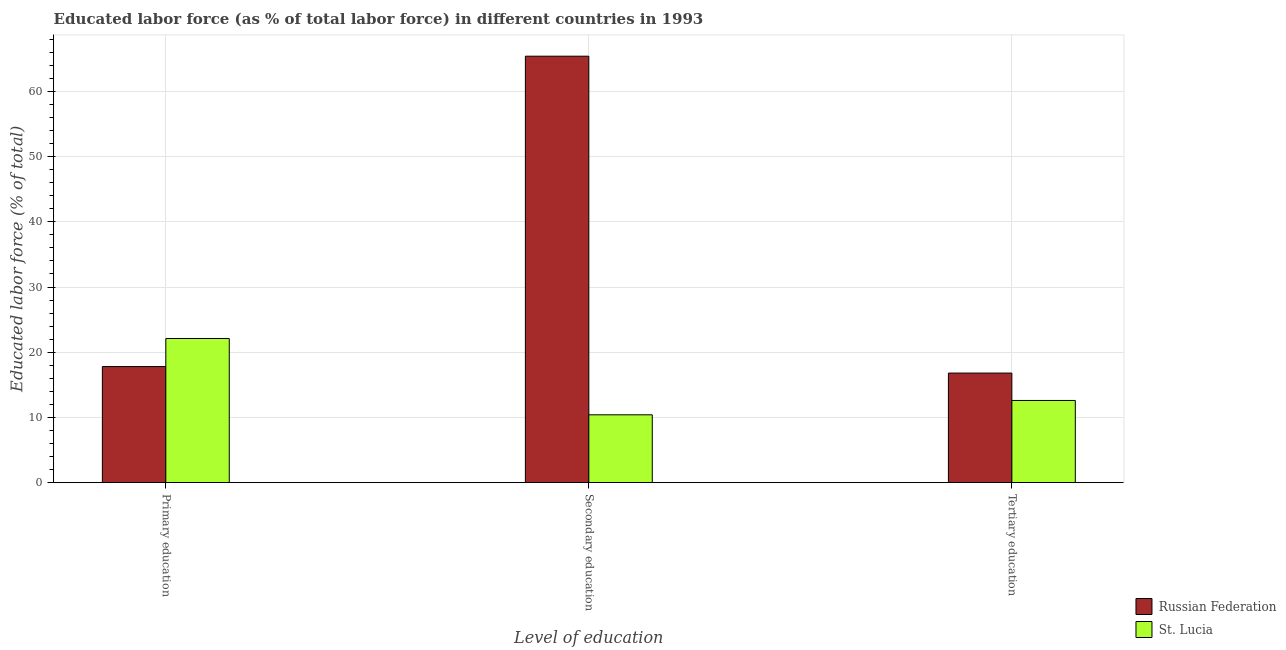How many groups of bars are there?
Offer a very short reply. 3. How many bars are there on the 3rd tick from the left?
Make the answer very short. 2. What is the label of the 3rd group of bars from the left?
Provide a succinct answer. Tertiary education. What is the percentage of labor force who received tertiary education in St. Lucia?
Offer a very short reply. 12.6. Across all countries, what is the maximum percentage of labor force who received tertiary education?
Give a very brief answer. 16.8. Across all countries, what is the minimum percentage of labor force who received tertiary education?
Provide a short and direct response. 12.6. In which country was the percentage of labor force who received secondary education maximum?
Offer a terse response. Russian Federation. In which country was the percentage of labor force who received tertiary education minimum?
Your response must be concise. St. Lucia. What is the total percentage of labor force who received tertiary education in the graph?
Provide a succinct answer. 29.4. What is the difference between the percentage of labor force who received secondary education in St. Lucia and that in Russian Federation?
Your answer should be very brief. -55. What is the difference between the percentage of labor force who received secondary education in Russian Federation and the percentage of labor force who received primary education in St. Lucia?
Make the answer very short. 43.3. What is the average percentage of labor force who received primary education per country?
Ensure brevity in your answer.  19.95. What is the difference between the percentage of labor force who received secondary education and percentage of labor force who received primary education in St. Lucia?
Your response must be concise. -11.7. In how many countries, is the percentage of labor force who received primary education greater than 16 %?
Your answer should be very brief. 2. What is the ratio of the percentage of labor force who received primary education in Russian Federation to that in St. Lucia?
Ensure brevity in your answer.  0.81. What is the difference between the highest and the second highest percentage of labor force who received secondary education?
Offer a terse response. 55. What is the difference between the highest and the lowest percentage of labor force who received secondary education?
Your answer should be very brief. 55. In how many countries, is the percentage of labor force who received primary education greater than the average percentage of labor force who received primary education taken over all countries?
Provide a short and direct response. 1. What does the 1st bar from the left in Secondary education represents?
Offer a very short reply. Russian Federation. What does the 2nd bar from the right in Tertiary education represents?
Ensure brevity in your answer.  Russian Federation. How many bars are there?
Your response must be concise. 6. How many countries are there in the graph?
Ensure brevity in your answer.  2. What is the difference between two consecutive major ticks on the Y-axis?
Ensure brevity in your answer.  10. Are the values on the major ticks of Y-axis written in scientific E-notation?
Offer a very short reply. No. Does the graph contain any zero values?
Provide a short and direct response. No. Does the graph contain grids?
Provide a short and direct response. Yes. Where does the legend appear in the graph?
Offer a very short reply. Bottom right. What is the title of the graph?
Offer a terse response. Educated labor force (as % of total labor force) in different countries in 1993. What is the label or title of the X-axis?
Keep it short and to the point. Level of education. What is the label or title of the Y-axis?
Provide a short and direct response. Educated labor force (% of total). What is the Educated labor force (% of total) in Russian Federation in Primary education?
Your response must be concise. 17.8. What is the Educated labor force (% of total) in St. Lucia in Primary education?
Your response must be concise. 22.1. What is the Educated labor force (% of total) in Russian Federation in Secondary education?
Ensure brevity in your answer.  65.4. What is the Educated labor force (% of total) in St. Lucia in Secondary education?
Your answer should be compact. 10.4. What is the Educated labor force (% of total) in Russian Federation in Tertiary education?
Your answer should be very brief. 16.8. What is the Educated labor force (% of total) of St. Lucia in Tertiary education?
Offer a very short reply. 12.6. Across all Level of education, what is the maximum Educated labor force (% of total) of Russian Federation?
Your answer should be compact. 65.4. Across all Level of education, what is the maximum Educated labor force (% of total) of St. Lucia?
Ensure brevity in your answer.  22.1. Across all Level of education, what is the minimum Educated labor force (% of total) of Russian Federation?
Keep it short and to the point. 16.8. Across all Level of education, what is the minimum Educated labor force (% of total) of St. Lucia?
Your answer should be very brief. 10.4. What is the total Educated labor force (% of total) in Russian Federation in the graph?
Your response must be concise. 100. What is the total Educated labor force (% of total) in St. Lucia in the graph?
Your answer should be very brief. 45.1. What is the difference between the Educated labor force (% of total) of Russian Federation in Primary education and that in Secondary education?
Provide a succinct answer. -47.6. What is the difference between the Educated labor force (% of total) in St. Lucia in Primary education and that in Secondary education?
Offer a very short reply. 11.7. What is the difference between the Educated labor force (% of total) of Russian Federation in Primary education and that in Tertiary education?
Ensure brevity in your answer.  1. What is the difference between the Educated labor force (% of total) in Russian Federation in Secondary education and that in Tertiary education?
Make the answer very short. 48.6. What is the difference between the Educated labor force (% of total) of St. Lucia in Secondary education and that in Tertiary education?
Keep it short and to the point. -2.2. What is the difference between the Educated labor force (% of total) of Russian Federation in Primary education and the Educated labor force (% of total) of St. Lucia in Tertiary education?
Your answer should be compact. 5.2. What is the difference between the Educated labor force (% of total) in Russian Federation in Secondary education and the Educated labor force (% of total) in St. Lucia in Tertiary education?
Offer a very short reply. 52.8. What is the average Educated labor force (% of total) in Russian Federation per Level of education?
Provide a succinct answer. 33.33. What is the average Educated labor force (% of total) in St. Lucia per Level of education?
Your response must be concise. 15.03. What is the difference between the Educated labor force (% of total) in Russian Federation and Educated labor force (% of total) in St. Lucia in Primary education?
Offer a terse response. -4.3. What is the difference between the Educated labor force (% of total) of Russian Federation and Educated labor force (% of total) of St. Lucia in Secondary education?
Provide a succinct answer. 55. What is the difference between the Educated labor force (% of total) in Russian Federation and Educated labor force (% of total) in St. Lucia in Tertiary education?
Provide a succinct answer. 4.2. What is the ratio of the Educated labor force (% of total) of Russian Federation in Primary education to that in Secondary education?
Offer a very short reply. 0.27. What is the ratio of the Educated labor force (% of total) in St. Lucia in Primary education to that in Secondary education?
Your response must be concise. 2.12. What is the ratio of the Educated labor force (% of total) of Russian Federation in Primary education to that in Tertiary education?
Keep it short and to the point. 1.06. What is the ratio of the Educated labor force (% of total) of St. Lucia in Primary education to that in Tertiary education?
Provide a succinct answer. 1.75. What is the ratio of the Educated labor force (% of total) in Russian Federation in Secondary education to that in Tertiary education?
Give a very brief answer. 3.89. What is the ratio of the Educated labor force (% of total) of St. Lucia in Secondary education to that in Tertiary education?
Give a very brief answer. 0.83. What is the difference between the highest and the second highest Educated labor force (% of total) in Russian Federation?
Provide a succinct answer. 47.6. What is the difference between the highest and the second highest Educated labor force (% of total) in St. Lucia?
Your answer should be very brief. 9.5. What is the difference between the highest and the lowest Educated labor force (% of total) in Russian Federation?
Give a very brief answer. 48.6. What is the difference between the highest and the lowest Educated labor force (% of total) in St. Lucia?
Keep it short and to the point. 11.7. 